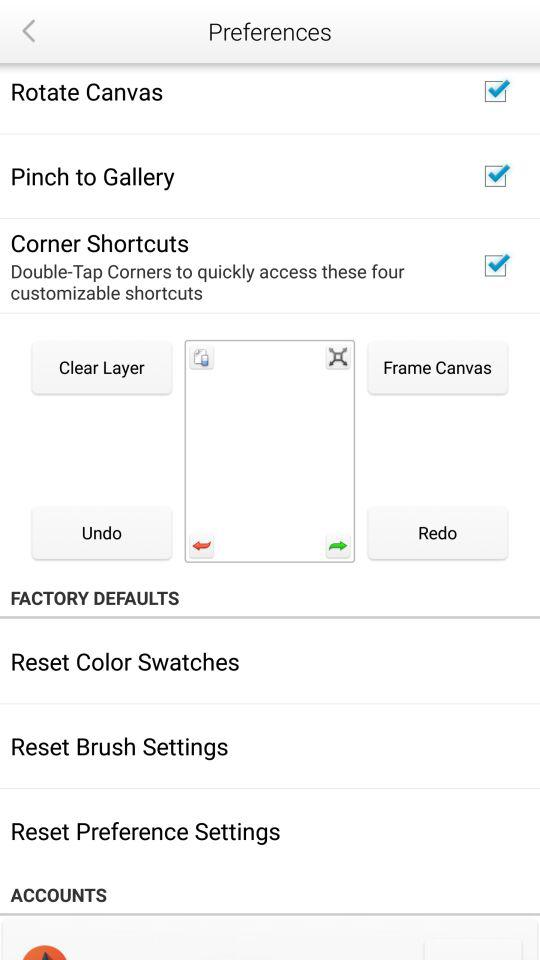What is the status of "Pinch to Gallery"? The status is "on". 